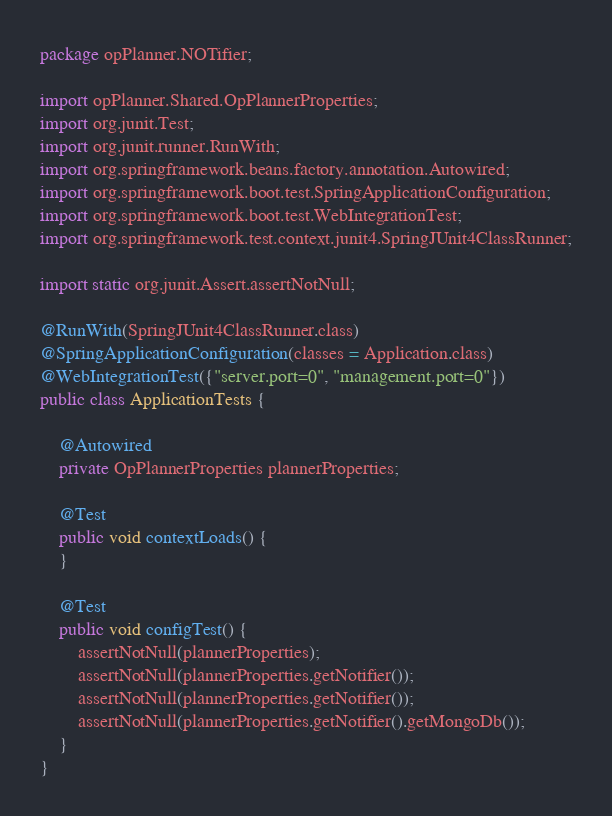Convert code to text. <code><loc_0><loc_0><loc_500><loc_500><_Java_>package opPlanner.NOTifier;

import opPlanner.Shared.OpPlannerProperties;
import org.junit.Test;
import org.junit.runner.RunWith;
import org.springframework.beans.factory.annotation.Autowired;
import org.springframework.boot.test.SpringApplicationConfiguration;
import org.springframework.boot.test.WebIntegrationTest;
import org.springframework.test.context.junit4.SpringJUnit4ClassRunner;

import static org.junit.Assert.assertNotNull;

@RunWith(SpringJUnit4ClassRunner.class)
@SpringApplicationConfiguration(classes = Application.class)
@WebIntegrationTest({"server.port=0", "management.port=0"})
public class ApplicationTests {

	@Autowired
	private OpPlannerProperties plannerProperties;

	@Test
	public void contextLoads() {
	}

	@Test
	public void configTest() {
		assertNotNull(plannerProperties);
		assertNotNull(plannerProperties.getNotifier());
		assertNotNull(plannerProperties.getNotifier());
		assertNotNull(plannerProperties.getNotifier().getMongoDb());
	}
}
</code> 